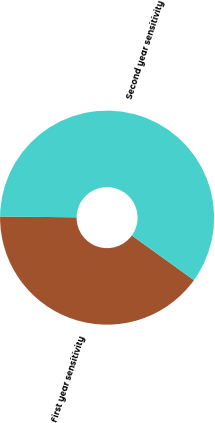<chart> <loc_0><loc_0><loc_500><loc_500><pie_chart><fcel>First year sensitivity<fcel>Second year sensitivity<nl><fcel>40.25%<fcel>59.75%<nl></chart> 